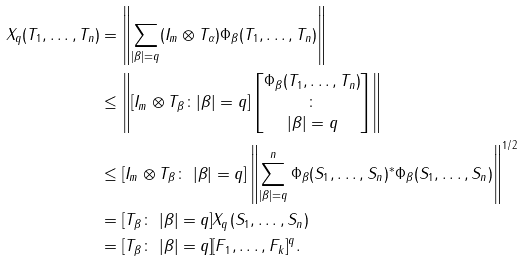Convert formula to latex. <formula><loc_0><loc_0><loc_500><loc_500>\| X _ { q } ( T _ { 1 } , \dots , T _ { n } ) \| & = \left \| \sum _ { | \beta | = q } ( I _ { m } \otimes T _ { \alpha } ) \Phi _ { \beta } ( T _ { 1 } , \dots , T _ { n } ) \right \| \\ & \leq \left \| [ I _ { m } \otimes T _ { \beta } \colon | \beta | = q ] \left [ \begin{matrix} \Phi _ { \beta } ( T _ { 1 } , \dots , T _ { n } ) \\ \colon \\ | \beta | = q \end{matrix} \right ] \right \| \\ & \leq \| [ I _ { m } \otimes T _ { \beta } \colon \ | \beta | = q ] \| \left \| \sum _ { | \beta | = q } ^ { n } \Phi _ { \beta } ( S _ { 1 } , \dots , S _ { n } ) ^ { * } \Phi _ { \beta } ( S _ { 1 } , \dots , S _ { n } ) \right \| ^ { 1 / 2 } \\ & = \| [ T _ { \beta } \colon \ | \beta | = q ] \| \| X _ { q } ( S _ { 1 } , \dots , S _ { n } ) \| \\ & = \| [ T _ { \beta } \colon \ | \beta | = q ] \| \| [ F _ { 1 } , \dots , F _ { k } ] \| ^ { q } .</formula> 